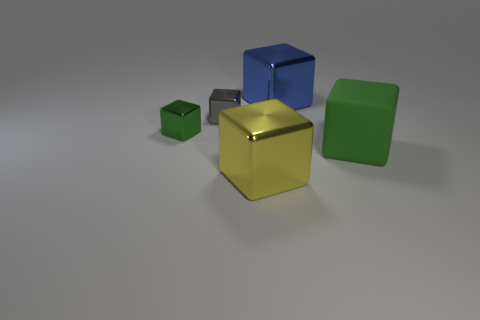Subtract all blue cylinders. How many green cubes are left? 2 Subtract all blue blocks. How many blocks are left? 4 Subtract all big blocks. How many blocks are left? 2 Subtract 3 blocks. How many blocks are left? 2 Add 4 large blue metallic objects. How many objects exist? 9 Subtract all cyan blocks. Subtract all gray cylinders. How many blocks are left? 5 Subtract all big yellow things. Subtract all big yellow metallic things. How many objects are left? 3 Add 4 blue blocks. How many blue blocks are left? 5 Add 3 brown metal balls. How many brown metal balls exist? 3 Subtract 0 yellow cylinders. How many objects are left? 5 